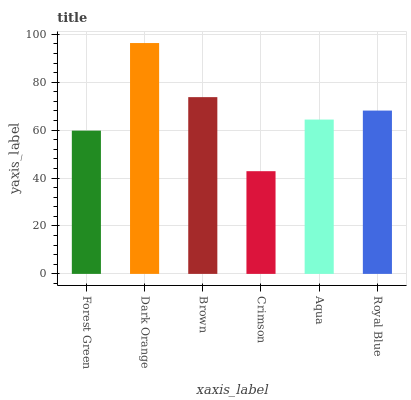Is Crimson the minimum?
Answer yes or no. Yes. Is Dark Orange the maximum?
Answer yes or no. Yes. Is Brown the minimum?
Answer yes or no. No. Is Brown the maximum?
Answer yes or no. No. Is Dark Orange greater than Brown?
Answer yes or no. Yes. Is Brown less than Dark Orange?
Answer yes or no. Yes. Is Brown greater than Dark Orange?
Answer yes or no. No. Is Dark Orange less than Brown?
Answer yes or no. No. Is Royal Blue the high median?
Answer yes or no. Yes. Is Aqua the low median?
Answer yes or no. Yes. Is Dark Orange the high median?
Answer yes or no. No. Is Dark Orange the low median?
Answer yes or no. No. 